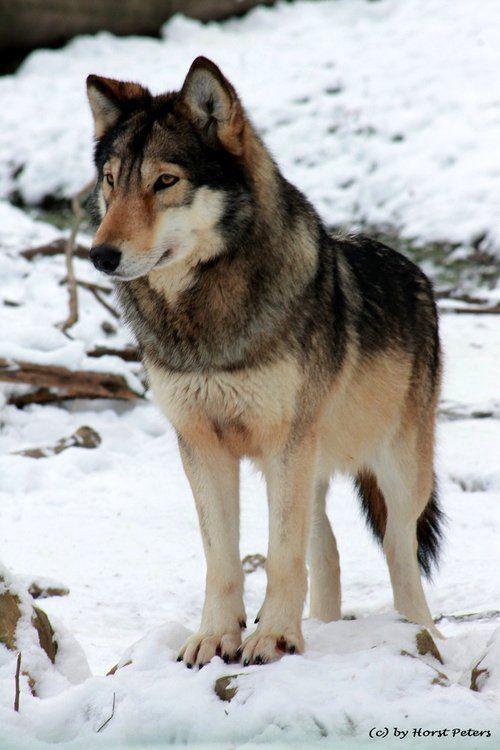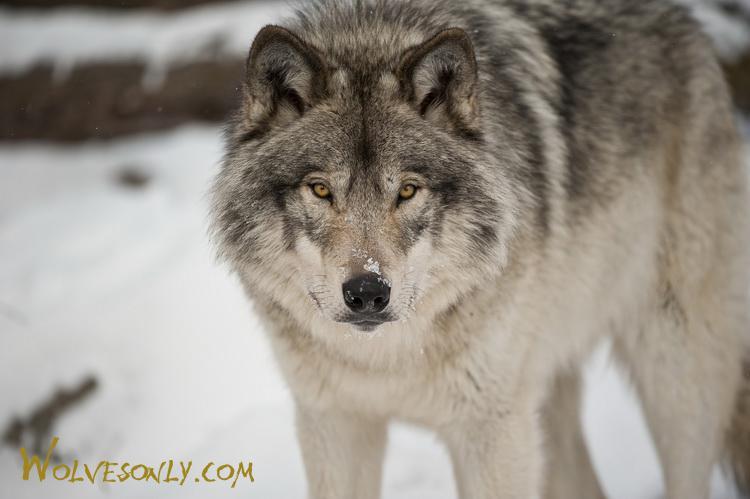The first image is the image on the left, the second image is the image on the right. For the images shown, is this caption "The right image contains multiple animals." true? Answer yes or no. No. The first image is the image on the left, the second image is the image on the right. Given the left and right images, does the statement "There is more than one wolf in the image on the right." hold true? Answer yes or no. No. 